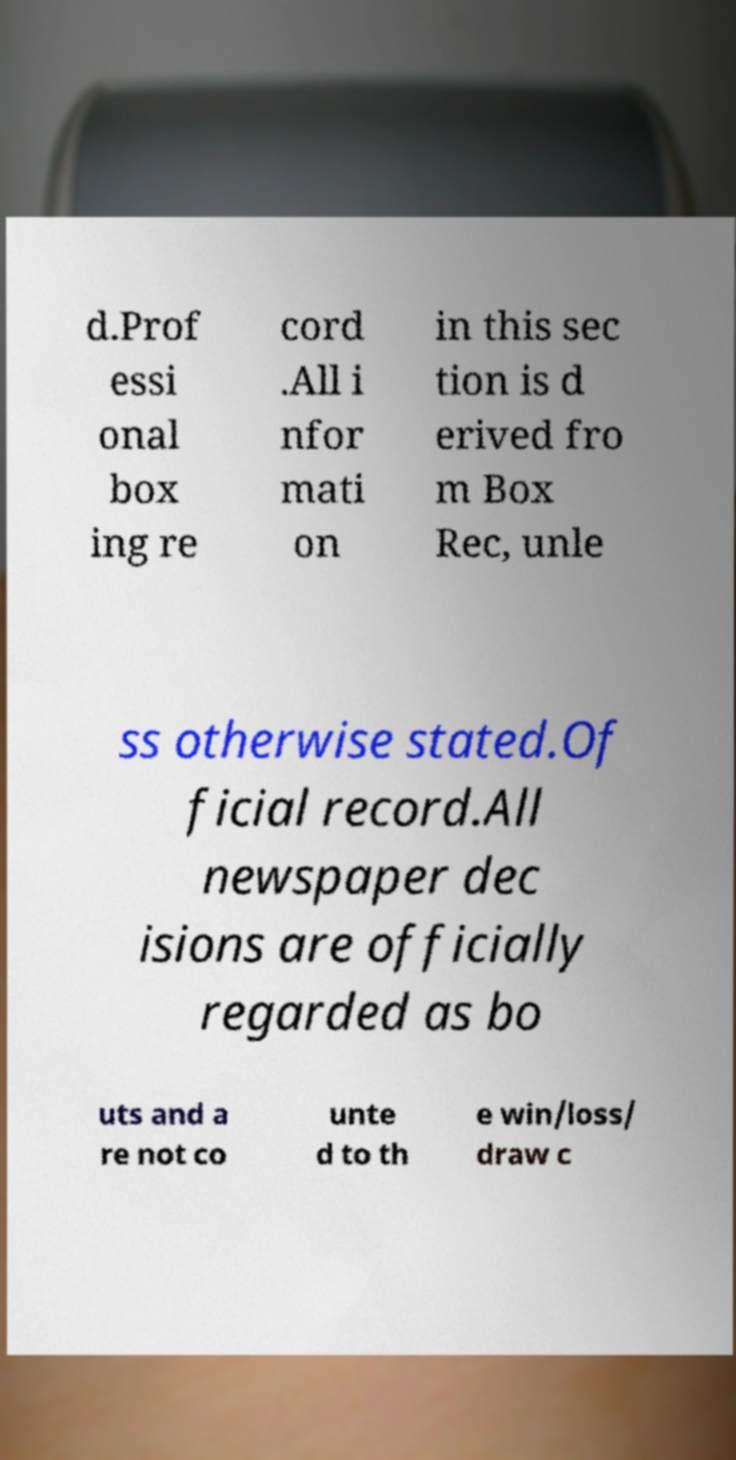Please identify and transcribe the text found in this image. d.Prof essi onal box ing re cord .All i nfor mati on in this sec tion is d erived fro m Box Rec, unle ss otherwise stated.Of ficial record.All newspaper dec isions are officially regarded as bo uts and a re not co unte d to th e win/loss/ draw c 